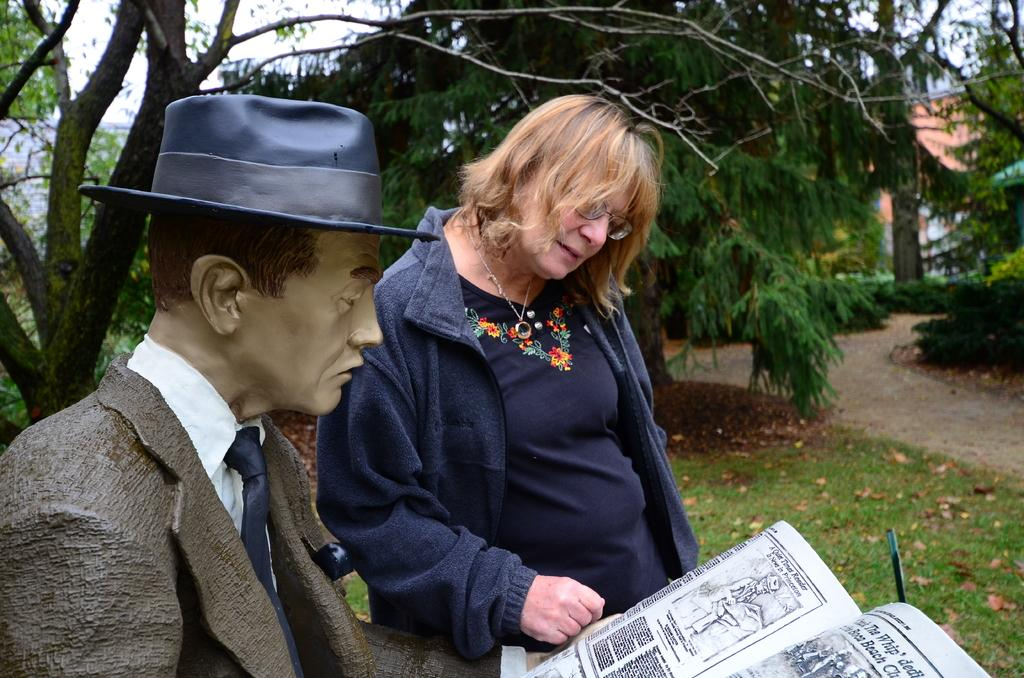What is the woman looking at in the image? The woman is standing beside the scepter and looking at the book. What is the scepter holding in the image? The scepter is holding a book in the image. What can be seen in the background of the image? There are trees and grass visible in the background of the image. What type of fan is visible in the image? There is no fan present in the image. Where is the end of the scepter located in the image? The scepter is holding a book in the image, so it does not have an end visible in the image. 